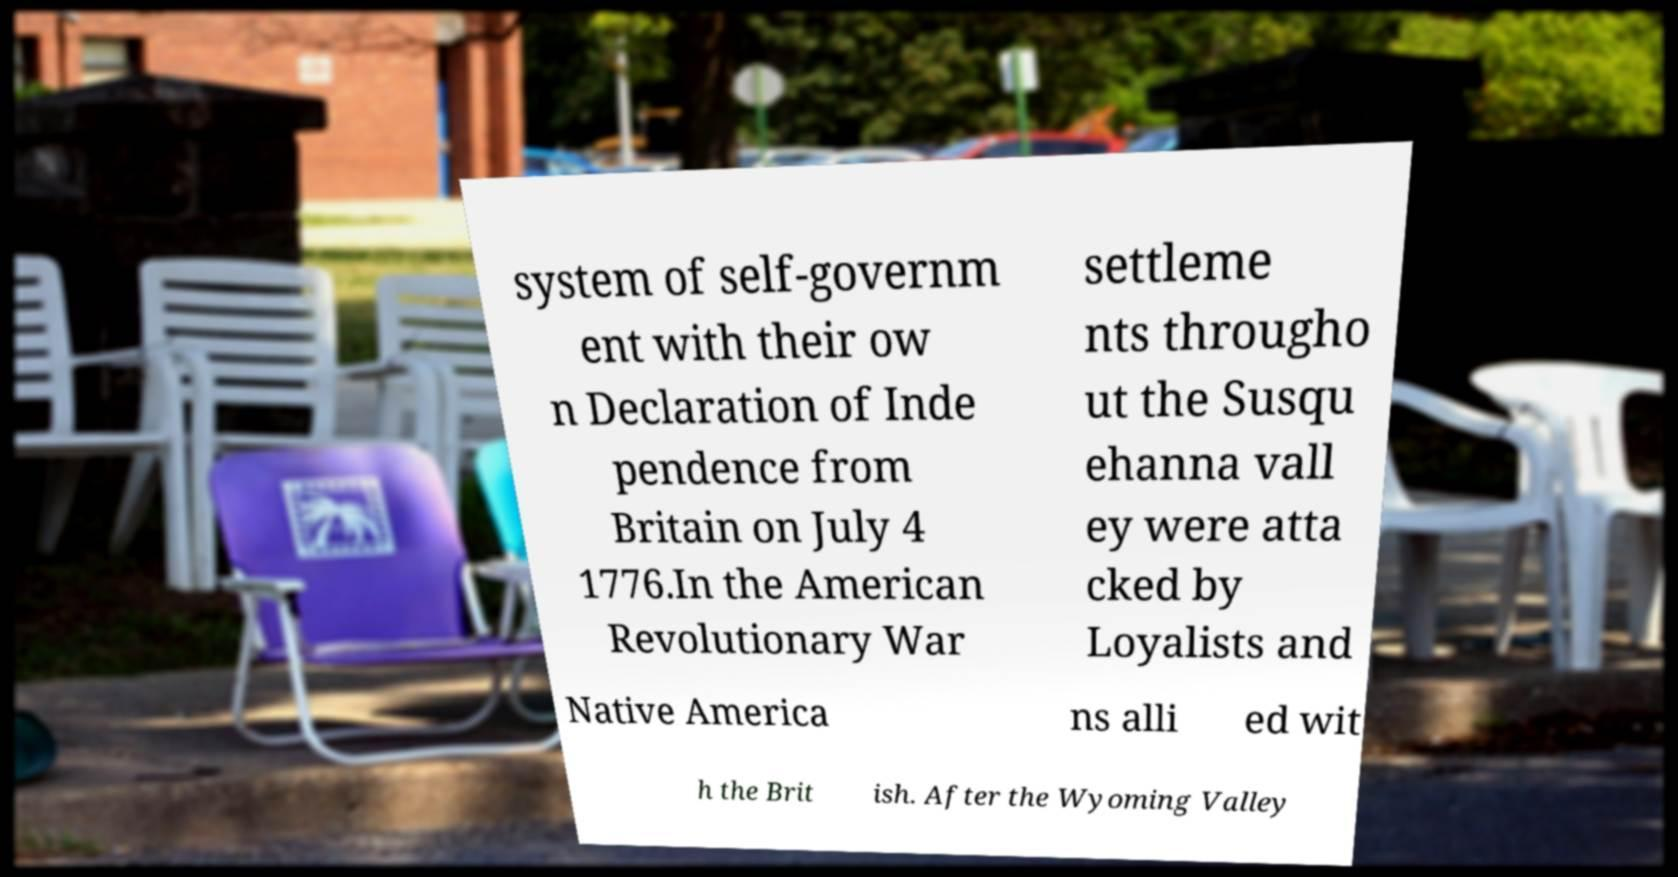I need the written content from this picture converted into text. Can you do that? system of self-governm ent with their ow n Declaration of Inde pendence from Britain on July 4 1776.In the American Revolutionary War settleme nts througho ut the Susqu ehanna vall ey were atta cked by Loyalists and Native America ns alli ed wit h the Brit ish. After the Wyoming Valley 